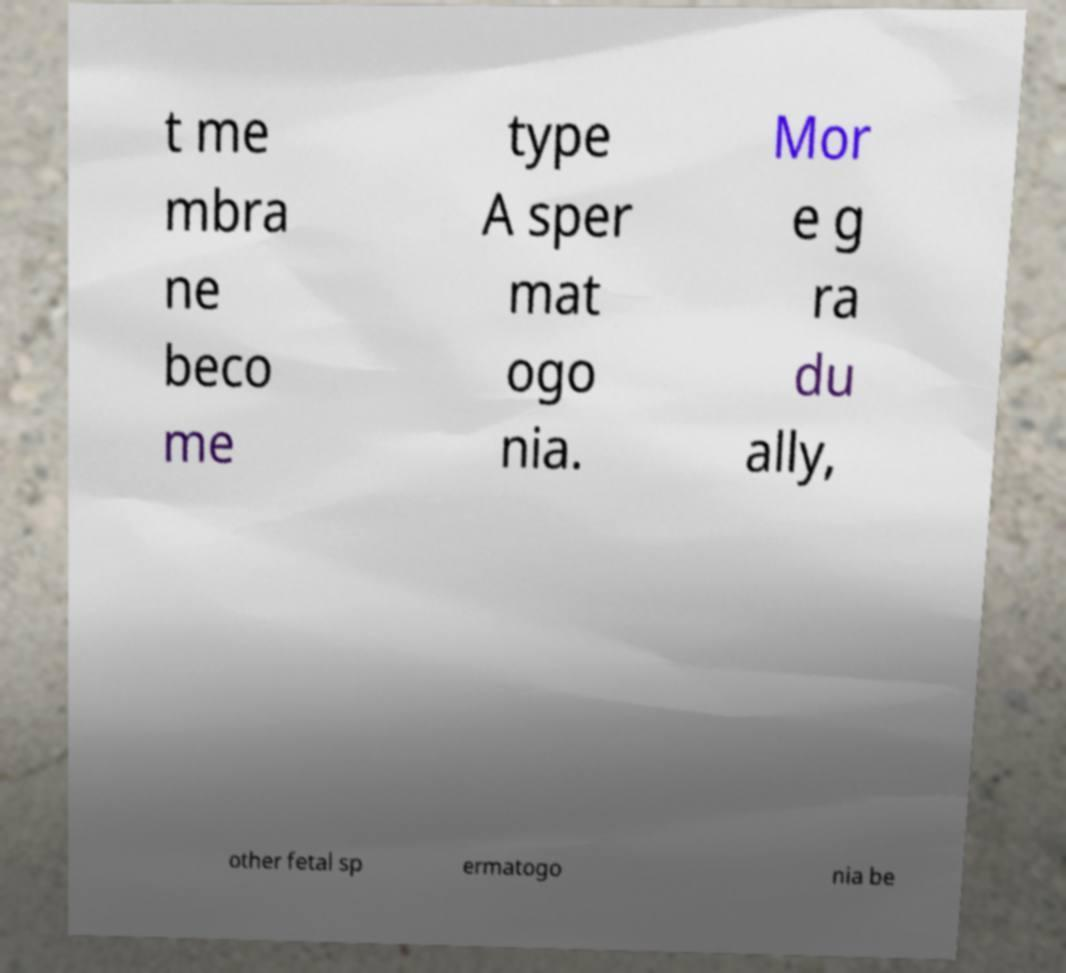Can you accurately transcribe the text from the provided image for me? t me mbra ne beco me type A sper mat ogo nia. Mor e g ra du ally, other fetal sp ermatogo nia be 